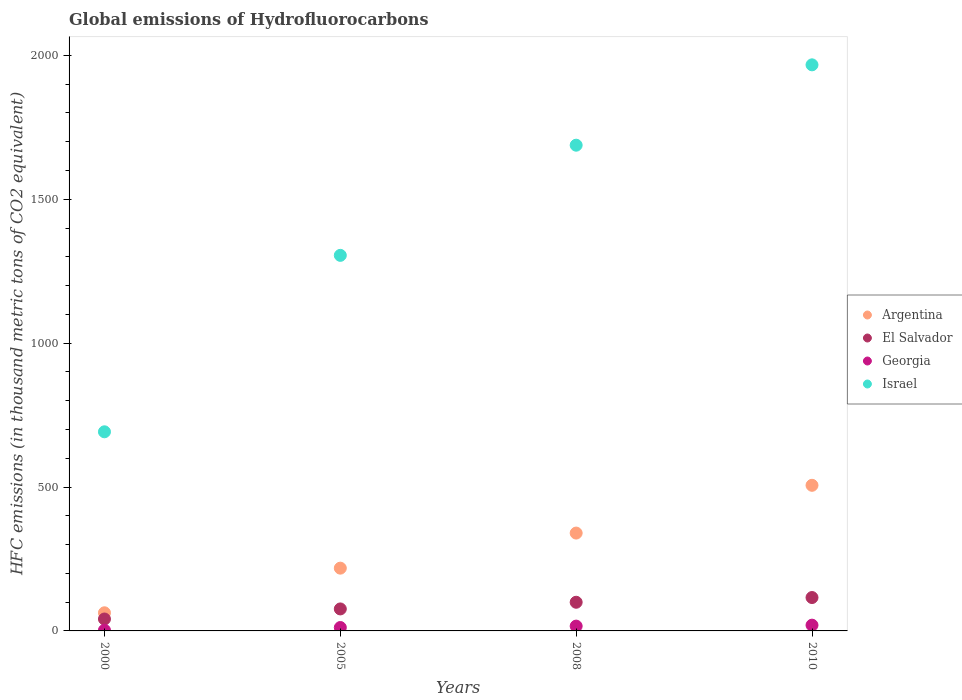How many different coloured dotlines are there?
Provide a short and direct response. 4. Across all years, what is the maximum global emissions of Hydrofluorocarbons in Israel?
Provide a succinct answer. 1967. Across all years, what is the minimum global emissions of Hydrofluorocarbons in Israel?
Provide a succinct answer. 691.9. In which year was the global emissions of Hydrofluorocarbons in Israel minimum?
Offer a terse response. 2000. What is the total global emissions of Hydrofluorocarbons in El Salvador in the graph?
Provide a short and direct response. 333.4. What is the difference between the global emissions of Hydrofluorocarbons in El Salvador in 2008 and that in 2010?
Offer a very short reply. -16.4. What is the difference between the global emissions of Hydrofluorocarbons in Georgia in 2000 and the global emissions of Hydrofluorocarbons in Argentina in 2008?
Provide a succinct answer. -337.5. What is the average global emissions of Hydrofluorocarbons in El Salvador per year?
Your answer should be very brief. 83.35. In the year 2000, what is the difference between the global emissions of Hydrofluorocarbons in Georgia and global emissions of Hydrofluorocarbons in Argentina?
Offer a very short reply. -60.5. In how many years, is the global emissions of Hydrofluorocarbons in Georgia greater than 1300 thousand metric tons?
Offer a very short reply. 0. What is the ratio of the global emissions of Hydrofluorocarbons in Israel in 2000 to that in 2010?
Provide a succinct answer. 0.35. Is the difference between the global emissions of Hydrofluorocarbons in Georgia in 2008 and 2010 greater than the difference between the global emissions of Hydrofluorocarbons in Argentina in 2008 and 2010?
Your response must be concise. Yes. What is the difference between the highest and the second highest global emissions of Hydrofluorocarbons in El Salvador?
Provide a short and direct response. 16.4. What is the difference between the highest and the lowest global emissions of Hydrofluorocarbons in Israel?
Provide a short and direct response. 1275.1. In how many years, is the global emissions of Hydrofluorocarbons in Argentina greater than the average global emissions of Hydrofluorocarbons in Argentina taken over all years?
Make the answer very short. 2. Is it the case that in every year, the sum of the global emissions of Hydrofluorocarbons in Argentina and global emissions of Hydrofluorocarbons in Georgia  is greater than the sum of global emissions of Hydrofluorocarbons in Israel and global emissions of Hydrofluorocarbons in El Salvador?
Your answer should be compact. No. How many years are there in the graph?
Ensure brevity in your answer.  4. What is the difference between two consecutive major ticks on the Y-axis?
Your answer should be compact. 500. Does the graph contain any zero values?
Make the answer very short. No. Does the graph contain grids?
Your answer should be compact. No. How many legend labels are there?
Provide a short and direct response. 4. What is the title of the graph?
Ensure brevity in your answer.  Global emissions of Hydrofluorocarbons. Does "Bahrain" appear as one of the legend labels in the graph?
Offer a terse response. No. What is the label or title of the X-axis?
Offer a very short reply. Years. What is the label or title of the Y-axis?
Provide a succinct answer. HFC emissions (in thousand metric tons of CO2 equivalent). What is the HFC emissions (in thousand metric tons of CO2 equivalent) of Argentina in 2000?
Make the answer very short. 63. What is the HFC emissions (in thousand metric tons of CO2 equivalent) of El Salvador in 2000?
Give a very brief answer. 41.4. What is the HFC emissions (in thousand metric tons of CO2 equivalent) in Georgia in 2000?
Offer a very short reply. 2.5. What is the HFC emissions (in thousand metric tons of CO2 equivalent) in Israel in 2000?
Make the answer very short. 691.9. What is the HFC emissions (in thousand metric tons of CO2 equivalent) of Argentina in 2005?
Your response must be concise. 218.1. What is the HFC emissions (in thousand metric tons of CO2 equivalent) of El Salvador in 2005?
Make the answer very short. 76.4. What is the HFC emissions (in thousand metric tons of CO2 equivalent) of Georgia in 2005?
Keep it short and to the point. 11.8. What is the HFC emissions (in thousand metric tons of CO2 equivalent) in Israel in 2005?
Give a very brief answer. 1305. What is the HFC emissions (in thousand metric tons of CO2 equivalent) in Argentina in 2008?
Your answer should be compact. 340. What is the HFC emissions (in thousand metric tons of CO2 equivalent) of El Salvador in 2008?
Keep it short and to the point. 99.6. What is the HFC emissions (in thousand metric tons of CO2 equivalent) in Georgia in 2008?
Offer a very short reply. 16.7. What is the HFC emissions (in thousand metric tons of CO2 equivalent) in Israel in 2008?
Make the answer very short. 1687.8. What is the HFC emissions (in thousand metric tons of CO2 equivalent) of Argentina in 2010?
Provide a short and direct response. 506. What is the HFC emissions (in thousand metric tons of CO2 equivalent) of El Salvador in 2010?
Offer a terse response. 116. What is the HFC emissions (in thousand metric tons of CO2 equivalent) in Georgia in 2010?
Make the answer very short. 20. What is the HFC emissions (in thousand metric tons of CO2 equivalent) of Israel in 2010?
Make the answer very short. 1967. Across all years, what is the maximum HFC emissions (in thousand metric tons of CO2 equivalent) of Argentina?
Give a very brief answer. 506. Across all years, what is the maximum HFC emissions (in thousand metric tons of CO2 equivalent) in El Salvador?
Ensure brevity in your answer.  116. Across all years, what is the maximum HFC emissions (in thousand metric tons of CO2 equivalent) of Georgia?
Provide a short and direct response. 20. Across all years, what is the maximum HFC emissions (in thousand metric tons of CO2 equivalent) of Israel?
Provide a short and direct response. 1967. Across all years, what is the minimum HFC emissions (in thousand metric tons of CO2 equivalent) of El Salvador?
Provide a succinct answer. 41.4. Across all years, what is the minimum HFC emissions (in thousand metric tons of CO2 equivalent) of Georgia?
Offer a very short reply. 2.5. Across all years, what is the minimum HFC emissions (in thousand metric tons of CO2 equivalent) of Israel?
Ensure brevity in your answer.  691.9. What is the total HFC emissions (in thousand metric tons of CO2 equivalent) of Argentina in the graph?
Make the answer very short. 1127.1. What is the total HFC emissions (in thousand metric tons of CO2 equivalent) of El Salvador in the graph?
Your answer should be compact. 333.4. What is the total HFC emissions (in thousand metric tons of CO2 equivalent) of Israel in the graph?
Your answer should be very brief. 5651.7. What is the difference between the HFC emissions (in thousand metric tons of CO2 equivalent) in Argentina in 2000 and that in 2005?
Give a very brief answer. -155.1. What is the difference between the HFC emissions (in thousand metric tons of CO2 equivalent) of El Salvador in 2000 and that in 2005?
Make the answer very short. -35. What is the difference between the HFC emissions (in thousand metric tons of CO2 equivalent) of Georgia in 2000 and that in 2005?
Provide a succinct answer. -9.3. What is the difference between the HFC emissions (in thousand metric tons of CO2 equivalent) of Israel in 2000 and that in 2005?
Keep it short and to the point. -613.1. What is the difference between the HFC emissions (in thousand metric tons of CO2 equivalent) of Argentina in 2000 and that in 2008?
Offer a very short reply. -277. What is the difference between the HFC emissions (in thousand metric tons of CO2 equivalent) of El Salvador in 2000 and that in 2008?
Give a very brief answer. -58.2. What is the difference between the HFC emissions (in thousand metric tons of CO2 equivalent) of Georgia in 2000 and that in 2008?
Provide a succinct answer. -14.2. What is the difference between the HFC emissions (in thousand metric tons of CO2 equivalent) in Israel in 2000 and that in 2008?
Provide a short and direct response. -995.9. What is the difference between the HFC emissions (in thousand metric tons of CO2 equivalent) of Argentina in 2000 and that in 2010?
Provide a short and direct response. -443. What is the difference between the HFC emissions (in thousand metric tons of CO2 equivalent) in El Salvador in 2000 and that in 2010?
Ensure brevity in your answer.  -74.6. What is the difference between the HFC emissions (in thousand metric tons of CO2 equivalent) of Georgia in 2000 and that in 2010?
Give a very brief answer. -17.5. What is the difference between the HFC emissions (in thousand metric tons of CO2 equivalent) of Israel in 2000 and that in 2010?
Provide a succinct answer. -1275.1. What is the difference between the HFC emissions (in thousand metric tons of CO2 equivalent) in Argentina in 2005 and that in 2008?
Offer a terse response. -121.9. What is the difference between the HFC emissions (in thousand metric tons of CO2 equivalent) of El Salvador in 2005 and that in 2008?
Your answer should be compact. -23.2. What is the difference between the HFC emissions (in thousand metric tons of CO2 equivalent) of Israel in 2005 and that in 2008?
Offer a very short reply. -382.8. What is the difference between the HFC emissions (in thousand metric tons of CO2 equivalent) of Argentina in 2005 and that in 2010?
Your answer should be compact. -287.9. What is the difference between the HFC emissions (in thousand metric tons of CO2 equivalent) of El Salvador in 2005 and that in 2010?
Your answer should be compact. -39.6. What is the difference between the HFC emissions (in thousand metric tons of CO2 equivalent) of Israel in 2005 and that in 2010?
Your answer should be very brief. -662. What is the difference between the HFC emissions (in thousand metric tons of CO2 equivalent) in Argentina in 2008 and that in 2010?
Your answer should be compact. -166. What is the difference between the HFC emissions (in thousand metric tons of CO2 equivalent) in El Salvador in 2008 and that in 2010?
Your response must be concise. -16.4. What is the difference between the HFC emissions (in thousand metric tons of CO2 equivalent) in Georgia in 2008 and that in 2010?
Ensure brevity in your answer.  -3.3. What is the difference between the HFC emissions (in thousand metric tons of CO2 equivalent) of Israel in 2008 and that in 2010?
Give a very brief answer. -279.2. What is the difference between the HFC emissions (in thousand metric tons of CO2 equivalent) of Argentina in 2000 and the HFC emissions (in thousand metric tons of CO2 equivalent) of Georgia in 2005?
Give a very brief answer. 51.2. What is the difference between the HFC emissions (in thousand metric tons of CO2 equivalent) of Argentina in 2000 and the HFC emissions (in thousand metric tons of CO2 equivalent) of Israel in 2005?
Provide a short and direct response. -1242. What is the difference between the HFC emissions (in thousand metric tons of CO2 equivalent) of El Salvador in 2000 and the HFC emissions (in thousand metric tons of CO2 equivalent) of Georgia in 2005?
Your answer should be compact. 29.6. What is the difference between the HFC emissions (in thousand metric tons of CO2 equivalent) in El Salvador in 2000 and the HFC emissions (in thousand metric tons of CO2 equivalent) in Israel in 2005?
Ensure brevity in your answer.  -1263.6. What is the difference between the HFC emissions (in thousand metric tons of CO2 equivalent) in Georgia in 2000 and the HFC emissions (in thousand metric tons of CO2 equivalent) in Israel in 2005?
Provide a short and direct response. -1302.5. What is the difference between the HFC emissions (in thousand metric tons of CO2 equivalent) in Argentina in 2000 and the HFC emissions (in thousand metric tons of CO2 equivalent) in El Salvador in 2008?
Give a very brief answer. -36.6. What is the difference between the HFC emissions (in thousand metric tons of CO2 equivalent) in Argentina in 2000 and the HFC emissions (in thousand metric tons of CO2 equivalent) in Georgia in 2008?
Offer a very short reply. 46.3. What is the difference between the HFC emissions (in thousand metric tons of CO2 equivalent) in Argentina in 2000 and the HFC emissions (in thousand metric tons of CO2 equivalent) in Israel in 2008?
Keep it short and to the point. -1624.8. What is the difference between the HFC emissions (in thousand metric tons of CO2 equivalent) in El Salvador in 2000 and the HFC emissions (in thousand metric tons of CO2 equivalent) in Georgia in 2008?
Offer a very short reply. 24.7. What is the difference between the HFC emissions (in thousand metric tons of CO2 equivalent) of El Salvador in 2000 and the HFC emissions (in thousand metric tons of CO2 equivalent) of Israel in 2008?
Your answer should be very brief. -1646.4. What is the difference between the HFC emissions (in thousand metric tons of CO2 equivalent) of Georgia in 2000 and the HFC emissions (in thousand metric tons of CO2 equivalent) of Israel in 2008?
Keep it short and to the point. -1685.3. What is the difference between the HFC emissions (in thousand metric tons of CO2 equivalent) in Argentina in 2000 and the HFC emissions (in thousand metric tons of CO2 equivalent) in El Salvador in 2010?
Keep it short and to the point. -53. What is the difference between the HFC emissions (in thousand metric tons of CO2 equivalent) of Argentina in 2000 and the HFC emissions (in thousand metric tons of CO2 equivalent) of Israel in 2010?
Ensure brevity in your answer.  -1904. What is the difference between the HFC emissions (in thousand metric tons of CO2 equivalent) in El Salvador in 2000 and the HFC emissions (in thousand metric tons of CO2 equivalent) in Georgia in 2010?
Provide a succinct answer. 21.4. What is the difference between the HFC emissions (in thousand metric tons of CO2 equivalent) of El Salvador in 2000 and the HFC emissions (in thousand metric tons of CO2 equivalent) of Israel in 2010?
Your answer should be very brief. -1925.6. What is the difference between the HFC emissions (in thousand metric tons of CO2 equivalent) in Georgia in 2000 and the HFC emissions (in thousand metric tons of CO2 equivalent) in Israel in 2010?
Make the answer very short. -1964.5. What is the difference between the HFC emissions (in thousand metric tons of CO2 equivalent) in Argentina in 2005 and the HFC emissions (in thousand metric tons of CO2 equivalent) in El Salvador in 2008?
Offer a very short reply. 118.5. What is the difference between the HFC emissions (in thousand metric tons of CO2 equivalent) in Argentina in 2005 and the HFC emissions (in thousand metric tons of CO2 equivalent) in Georgia in 2008?
Give a very brief answer. 201.4. What is the difference between the HFC emissions (in thousand metric tons of CO2 equivalent) in Argentina in 2005 and the HFC emissions (in thousand metric tons of CO2 equivalent) in Israel in 2008?
Provide a short and direct response. -1469.7. What is the difference between the HFC emissions (in thousand metric tons of CO2 equivalent) of El Salvador in 2005 and the HFC emissions (in thousand metric tons of CO2 equivalent) of Georgia in 2008?
Your response must be concise. 59.7. What is the difference between the HFC emissions (in thousand metric tons of CO2 equivalent) of El Salvador in 2005 and the HFC emissions (in thousand metric tons of CO2 equivalent) of Israel in 2008?
Your response must be concise. -1611.4. What is the difference between the HFC emissions (in thousand metric tons of CO2 equivalent) in Georgia in 2005 and the HFC emissions (in thousand metric tons of CO2 equivalent) in Israel in 2008?
Your answer should be very brief. -1676. What is the difference between the HFC emissions (in thousand metric tons of CO2 equivalent) in Argentina in 2005 and the HFC emissions (in thousand metric tons of CO2 equivalent) in El Salvador in 2010?
Offer a very short reply. 102.1. What is the difference between the HFC emissions (in thousand metric tons of CO2 equivalent) in Argentina in 2005 and the HFC emissions (in thousand metric tons of CO2 equivalent) in Georgia in 2010?
Provide a short and direct response. 198.1. What is the difference between the HFC emissions (in thousand metric tons of CO2 equivalent) in Argentina in 2005 and the HFC emissions (in thousand metric tons of CO2 equivalent) in Israel in 2010?
Make the answer very short. -1748.9. What is the difference between the HFC emissions (in thousand metric tons of CO2 equivalent) of El Salvador in 2005 and the HFC emissions (in thousand metric tons of CO2 equivalent) of Georgia in 2010?
Your answer should be compact. 56.4. What is the difference between the HFC emissions (in thousand metric tons of CO2 equivalent) of El Salvador in 2005 and the HFC emissions (in thousand metric tons of CO2 equivalent) of Israel in 2010?
Make the answer very short. -1890.6. What is the difference between the HFC emissions (in thousand metric tons of CO2 equivalent) of Georgia in 2005 and the HFC emissions (in thousand metric tons of CO2 equivalent) of Israel in 2010?
Your answer should be very brief. -1955.2. What is the difference between the HFC emissions (in thousand metric tons of CO2 equivalent) in Argentina in 2008 and the HFC emissions (in thousand metric tons of CO2 equivalent) in El Salvador in 2010?
Give a very brief answer. 224. What is the difference between the HFC emissions (in thousand metric tons of CO2 equivalent) in Argentina in 2008 and the HFC emissions (in thousand metric tons of CO2 equivalent) in Georgia in 2010?
Keep it short and to the point. 320. What is the difference between the HFC emissions (in thousand metric tons of CO2 equivalent) in Argentina in 2008 and the HFC emissions (in thousand metric tons of CO2 equivalent) in Israel in 2010?
Offer a very short reply. -1627. What is the difference between the HFC emissions (in thousand metric tons of CO2 equivalent) in El Salvador in 2008 and the HFC emissions (in thousand metric tons of CO2 equivalent) in Georgia in 2010?
Your response must be concise. 79.6. What is the difference between the HFC emissions (in thousand metric tons of CO2 equivalent) of El Salvador in 2008 and the HFC emissions (in thousand metric tons of CO2 equivalent) of Israel in 2010?
Keep it short and to the point. -1867.4. What is the difference between the HFC emissions (in thousand metric tons of CO2 equivalent) in Georgia in 2008 and the HFC emissions (in thousand metric tons of CO2 equivalent) in Israel in 2010?
Your answer should be compact. -1950.3. What is the average HFC emissions (in thousand metric tons of CO2 equivalent) of Argentina per year?
Your answer should be compact. 281.77. What is the average HFC emissions (in thousand metric tons of CO2 equivalent) in El Salvador per year?
Your answer should be very brief. 83.35. What is the average HFC emissions (in thousand metric tons of CO2 equivalent) in Georgia per year?
Ensure brevity in your answer.  12.75. What is the average HFC emissions (in thousand metric tons of CO2 equivalent) in Israel per year?
Your answer should be compact. 1412.92. In the year 2000, what is the difference between the HFC emissions (in thousand metric tons of CO2 equivalent) in Argentina and HFC emissions (in thousand metric tons of CO2 equivalent) in El Salvador?
Offer a very short reply. 21.6. In the year 2000, what is the difference between the HFC emissions (in thousand metric tons of CO2 equivalent) in Argentina and HFC emissions (in thousand metric tons of CO2 equivalent) in Georgia?
Your response must be concise. 60.5. In the year 2000, what is the difference between the HFC emissions (in thousand metric tons of CO2 equivalent) in Argentina and HFC emissions (in thousand metric tons of CO2 equivalent) in Israel?
Provide a succinct answer. -628.9. In the year 2000, what is the difference between the HFC emissions (in thousand metric tons of CO2 equivalent) in El Salvador and HFC emissions (in thousand metric tons of CO2 equivalent) in Georgia?
Provide a succinct answer. 38.9. In the year 2000, what is the difference between the HFC emissions (in thousand metric tons of CO2 equivalent) of El Salvador and HFC emissions (in thousand metric tons of CO2 equivalent) of Israel?
Your answer should be very brief. -650.5. In the year 2000, what is the difference between the HFC emissions (in thousand metric tons of CO2 equivalent) of Georgia and HFC emissions (in thousand metric tons of CO2 equivalent) of Israel?
Provide a short and direct response. -689.4. In the year 2005, what is the difference between the HFC emissions (in thousand metric tons of CO2 equivalent) of Argentina and HFC emissions (in thousand metric tons of CO2 equivalent) of El Salvador?
Your response must be concise. 141.7. In the year 2005, what is the difference between the HFC emissions (in thousand metric tons of CO2 equivalent) in Argentina and HFC emissions (in thousand metric tons of CO2 equivalent) in Georgia?
Give a very brief answer. 206.3. In the year 2005, what is the difference between the HFC emissions (in thousand metric tons of CO2 equivalent) of Argentina and HFC emissions (in thousand metric tons of CO2 equivalent) of Israel?
Your answer should be very brief. -1086.9. In the year 2005, what is the difference between the HFC emissions (in thousand metric tons of CO2 equivalent) in El Salvador and HFC emissions (in thousand metric tons of CO2 equivalent) in Georgia?
Offer a terse response. 64.6. In the year 2005, what is the difference between the HFC emissions (in thousand metric tons of CO2 equivalent) of El Salvador and HFC emissions (in thousand metric tons of CO2 equivalent) of Israel?
Keep it short and to the point. -1228.6. In the year 2005, what is the difference between the HFC emissions (in thousand metric tons of CO2 equivalent) of Georgia and HFC emissions (in thousand metric tons of CO2 equivalent) of Israel?
Keep it short and to the point. -1293.2. In the year 2008, what is the difference between the HFC emissions (in thousand metric tons of CO2 equivalent) in Argentina and HFC emissions (in thousand metric tons of CO2 equivalent) in El Salvador?
Provide a short and direct response. 240.4. In the year 2008, what is the difference between the HFC emissions (in thousand metric tons of CO2 equivalent) of Argentina and HFC emissions (in thousand metric tons of CO2 equivalent) of Georgia?
Make the answer very short. 323.3. In the year 2008, what is the difference between the HFC emissions (in thousand metric tons of CO2 equivalent) of Argentina and HFC emissions (in thousand metric tons of CO2 equivalent) of Israel?
Provide a succinct answer. -1347.8. In the year 2008, what is the difference between the HFC emissions (in thousand metric tons of CO2 equivalent) in El Salvador and HFC emissions (in thousand metric tons of CO2 equivalent) in Georgia?
Your answer should be compact. 82.9. In the year 2008, what is the difference between the HFC emissions (in thousand metric tons of CO2 equivalent) in El Salvador and HFC emissions (in thousand metric tons of CO2 equivalent) in Israel?
Ensure brevity in your answer.  -1588.2. In the year 2008, what is the difference between the HFC emissions (in thousand metric tons of CO2 equivalent) in Georgia and HFC emissions (in thousand metric tons of CO2 equivalent) in Israel?
Offer a very short reply. -1671.1. In the year 2010, what is the difference between the HFC emissions (in thousand metric tons of CO2 equivalent) of Argentina and HFC emissions (in thousand metric tons of CO2 equivalent) of El Salvador?
Your answer should be very brief. 390. In the year 2010, what is the difference between the HFC emissions (in thousand metric tons of CO2 equivalent) of Argentina and HFC emissions (in thousand metric tons of CO2 equivalent) of Georgia?
Your answer should be compact. 486. In the year 2010, what is the difference between the HFC emissions (in thousand metric tons of CO2 equivalent) in Argentina and HFC emissions (in thousand metric tons of CO2 equivalent) in Israel?
Offer a terse response. -1461. In the year 2010, what is the difference between the HFC emissions (in thousand metric tons of CO2 equivalent) in El Salvador and HFC emissions (in thousand metric tons of CO2 equivalent) in Georgia?
Make the answer very short. 96. In the year 2010, what is the difference between the HFC emissions (in thousand metric tons of CO2 equivalent) in El Salvador and HFC emissions (in thousand metric tons of CO2 equivalent) in Israel?
Provide a succinct answer. -1851. In the year 2010, what is the difference between the HFC emissions (in thousand metric tons of CO2 equivalent) of Georgia and HFC emissions (in thousand metric tons of CO2 equivalent) of Israel?
Ensure brevity in your answer.  -1947. What is the ratio of the HFC emissions (in thousand metric tons of CO2 equivalent) of Argentina in 2000 to that in 2005?
Provide a succinct answer. 0.29. What is the ratio of the HFC emissions (in thousand metric tons of CO2 equivalent) of El Salvador in 2000 to that in 2005?
Provide a short and direct response. 0.54. What is the ratio of the HFC emissions (in thousand metric tons of CO2 equivalent) in Georgia in 2000 to that in 2005?
Make the answer very short. 0.21. What is the ratio of the HFC emissions (in thousand metric tons of CO2 equivalent) of Israel in 2000 to that in 2005?
Keep it short and to the point. 0.53. What is the ratio of the HFC emissions (in thousand metric tons of CO2 equivalent) of Argentina in 2000 to that in 2008?
Keep it short and to the point. 0.19. What is the ratio of the HFC emissions (in thousand metric tons of CO2 equivalent) in El Salvador in 2000 to that in 2008?
Offer a terse response. 0.42. What is the ratio of the HFC emissions (in thousand metric tons of CO2 equivalent) in Georgia in 2000 to that in 2008?
Your answer should be very brief. 0.15. What is the ratio of the HFC emissions (in thousand metric tons of CO2 equivalent) of Israel in 2000 to that in 2008?
Offer a terse response. 0.41. What is the ratio of the HFC emissions (in thousand metric tons of CO2 equivalent) of Argentina in 2000 to that in 2010?
Provide a succinct answer. 0.12. What is the ratio of the HFC emissions (in thousand metric tons of CO2 equivalent) of El Salvador in 2000 to that in 2010?
Offer a terse response. 0.36. What is the ratio of the HFC emissions (in thousand metric tons of CO2 equivalent) in Israel in 2000 to that in 2010?
Give a very brief answer. 0.35. What is the ratio of the HFC emissions (in thousand metric tons of CO2 equivalent) of Argentina in 2005 to that in 2008?
Ensure brevity in your answer.  0.64. What is the ratio of the HFC emissions (in thousand metric tons of CO2 equivalent) in El Salvador in 2005 to that in 2008?
Ensure brevity in your answer.  0.77. What is the ratio of the HFC emissions (in thousand metric tons of CO2 equivalent) in Georgia in 2005 to that in 2008?
Make the answer very short. 0.71. What is the ratio of the HFC emissions (in thousand metric tons of CO2 equivalent) of Israel in 2005 to that in 2008?
Offer a very short reply. 0.77. What is the ratio of the HFC emissions (in thousand metric tons of CO2 equivalent) of Argentina in 2005 to that in 2010?
Provide a short and direct response. 0.43. What is the ratio of the HFC emissions (in thousand metric tons of CO2 equivalent) in El Salvador in 2005 to that in 2010?
Give a very brief answer. 0.66. What is the ratio of the HFC emissions (in thousand metric tons of CO2 equivalent) in Georgia in 2005 to that in 2010?
Offer a very short reply. 0.59. What is the ratio of the HFC emissions (in thousand metric tons of CO2 equivalent) of Israel in 2005 to that in 2010?
Give a very brief answer. 0.66. What is the ratio of the HFC emissions (in thousand metric tons of CO2 equivalent) in Argentina in 2008 to that in 2010?
Your answer should be compact. 0.67. What is the ratio of the HFC emissions (in thousand metric tons of CO2 equivalent) of El Salvador in 2008 to that in 2010?
Keep it short and to the point. 0.86. What is the ratio of the HFC emissions (in thousand metric tons of CO2 equivalent) in Georgia in 2008 to that in 2010?
Offer a terse response. 0.83. What is the ratio of the HFC emissions (in thousand metric tons of CO2 equivalent) of Israel in 2008 to that in 2010?
Provide a short and direct response. 0.86. What is the difference between the highest and the second highest HFC emissions (in thousand metric tons of CO2 equivalent) of Argentina?
Offer a very short reply. 166. What is the difference between the highest and the second highest HFC emissions (in thousand metric tons of CO2 equivalent) of Georgia?
Give a very brief answer. 3.3. What is the difference between the highest and the second highest HFC emissions (in thousand metric tons of CO2 equivalent) of Israel?
Offer a terse response. 279.2. What is the difference between the highest and the lowest HFC emissions (in thousand metric tons of CO2 equivalent) of Argentina?
Keep it short and to the point. 443. What is the difference between the highest and the lowest HFC emissions (in thousand metric tons of CO2 equivalent) of El Salvador?
Give a very brief answer. 74.6. What is the difference between the highest and the lowest HFC emissions (in thousand metric tons of CO2 equivalent) in Israel?
Keep it short and to the point. 1275.1. 